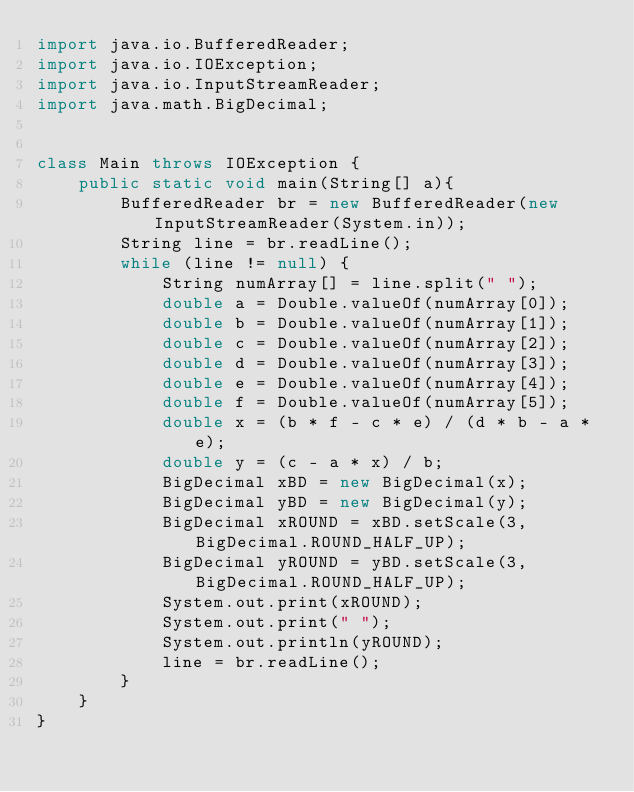Convert code to text. <code><loc_0><loc_0><loc_500><loc_500><_Java_>import java.io.BufferedReader;
import java.io.IOException;
import java.io.InputStreamReader;
import java.math.BigDecimal;


class Main throws IOException {
    public static void main(String[] a){
		BufferedReader br = new BufferedReader(new InputStreamReader(System.in));
		String line = br.readLine();
		while (line != null) {
			String numArray[] = line.split(" ");
			double a = Double.valueOf(numArray[0]);
			double b = Double.valueOf(numArray[1]);
			double c = Double.valueOf(numArray[2]);
			double d = Double.valueOf(numArray[3]);
			double e = Double.valueOf(numArray[4]);
			double f = Double.valueOf(numArray[5]);
			double x = (b * f - c * e) / (d * b - a * e);
			double y = (c - a * x) / b;
			BigDecimal xBD = new BigDecimal(x);
			BigDecimal yBD = new BigDecimal(y);
			BigDecimal xROUND = xBD.setScale(3, BigDecimal.ROUND_HALF_UP);
			BigDecimal yROUND = yBD.setScale(3, BigDecimal.ROUND_HALF_UP);
			System.out.print(xROUND);
			System.out.print(" ");
			System.out.println(yROUND);
			line = br.readLine();
		}
    }
}</code> 